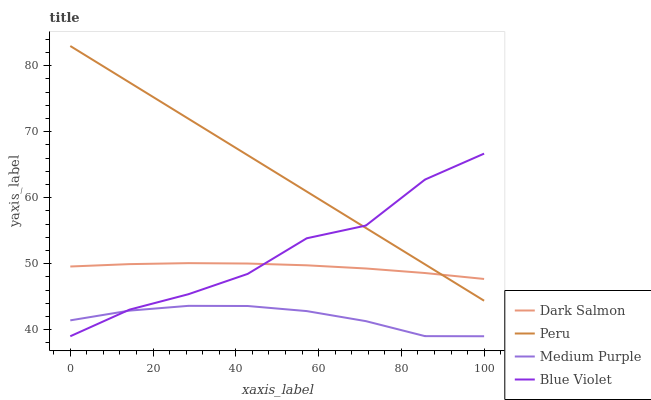Does Medium Purple have the minimum area under the curve?
Answer yes or no. Yes. Does Peru have the maximum area under the curve?
Answer yes or no. Yes. Does Blue Violet have the minimum area under the curve?
Answer yes or no. No. Does Blue Violet have the maximum area under the curve?
Answer yes or no. No. Is Peru the smoothest?
Answer yes or no. Yes. Is Blue Violet the roughest?
Answer yes or no. Yes. Is Dark Salmon the smoothest?
Answer yes or no. No. Is Dark Salmon the roughest?
Answer yes or no. No. Does Medium Purple have the lowest value?
Answer yes or no. Yes. Does Dark Salmon have the lowest value?
Answer yes or no. No. Does Peru have the highest value?
Answer yes or no. Yes. Does Blue Violet have the highest value?
Answer yes or no. No. Is Medium Purple less than Dark Salmon?
Answer yes or no. Yes. Is Dark Salmon greater than Medium Purple?
Answer yes or no. Yes. Does Blue Violet intersect Dark Salmon?
Answer yes or no. Yes. Is Blue Violet less than Dark Salmon?
Answer yes or no. No. Is Blue Violet greater than Dark Salmon?
Answer yes or no. No. Does Medium Purple intersect Dark Salmon?
Answer yes or no. No. 